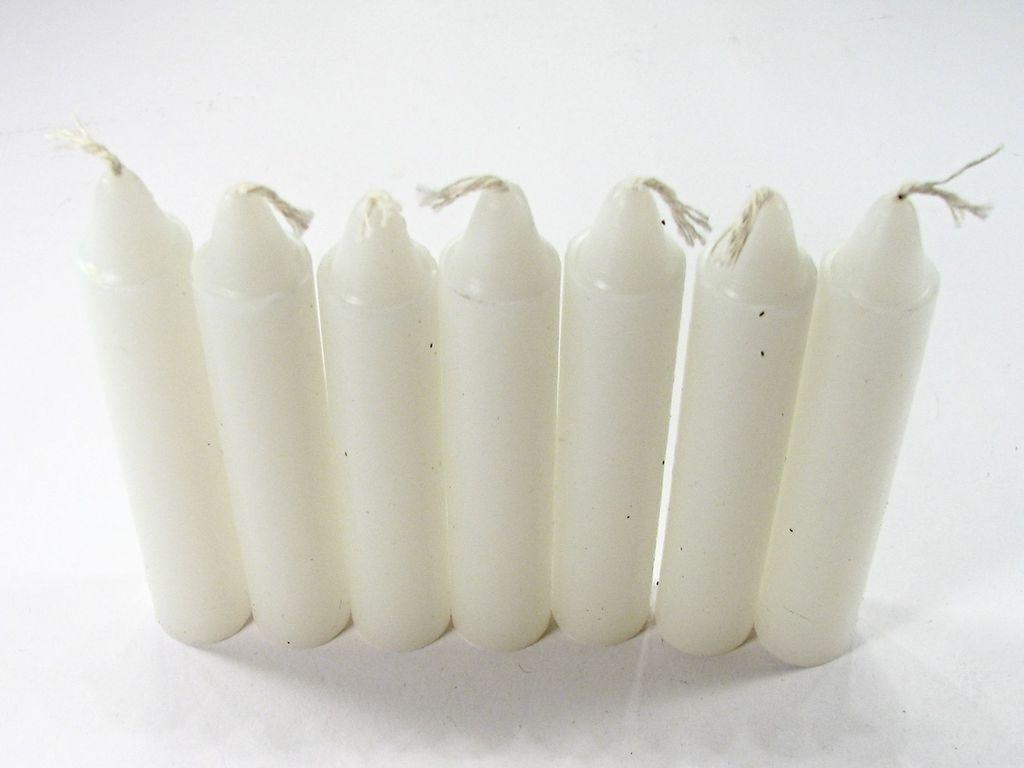What type of objects are in the center of the image? There are white-colored candles in the center of the image. Can you describe the color of the candles? The candles are white-colored. How many screws can be seen holding the brick in place in the image? There are no screws or bricks present in the image; it only features white-colored candles. 